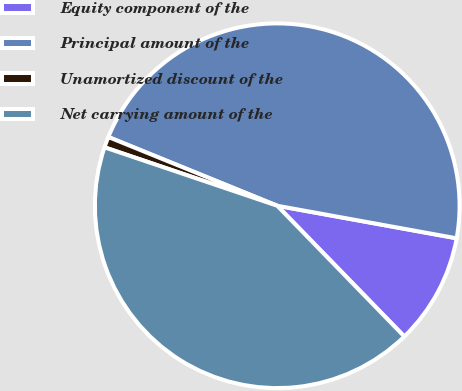Convert chart to OTSL. <chart><loc_0><loc_0><loc_500><loc_500><pie_chart><fcel>Equity component of the<fcel>Principal amount of the<fcel>Unamortized discount of the<fcel>Net carrying amount of the<nl><fcel>9.87%<fcel>46.71%<fcel>0.96%<fcel>42.47%<nl></chart> 